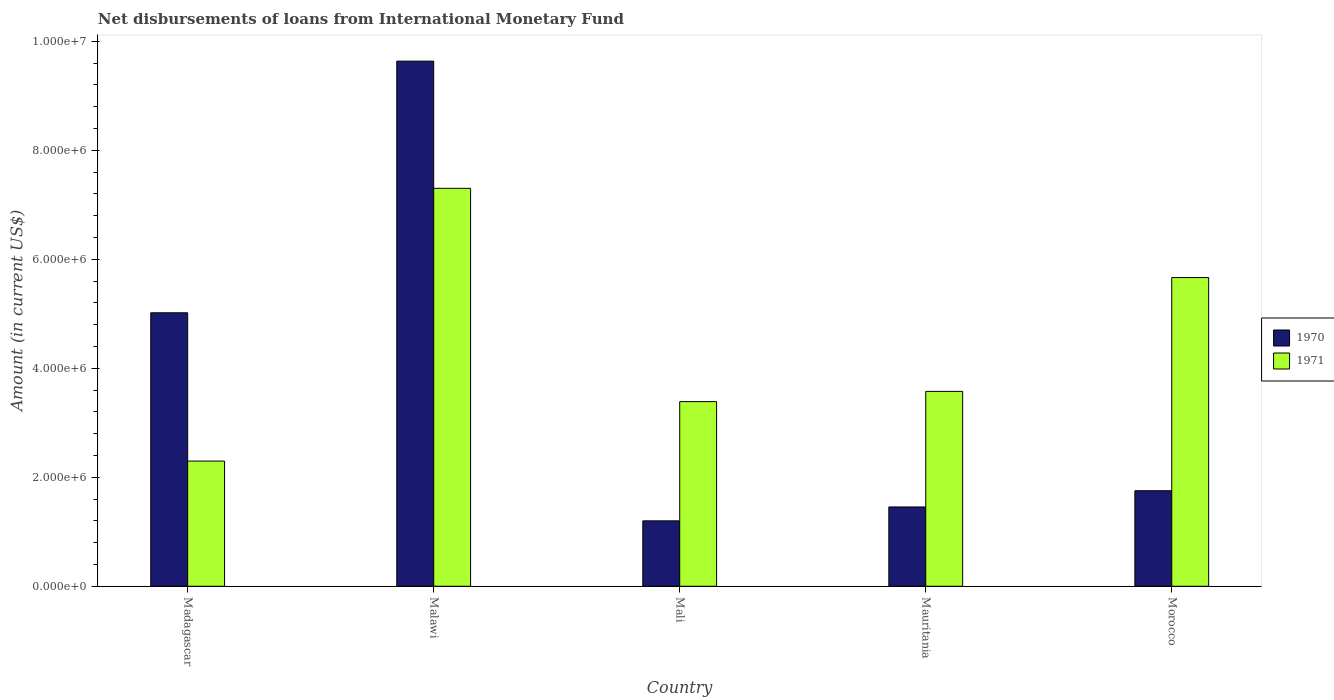How many different coloured bars are there?
Offer a very short reply. 2. How many groups of bars are there?
Make the answer very short. 5. Are the number of bars per tick equal to the number of legend labels?
Provide a short and direct response. Yes. Are the number of bars on each tick of the X-axis equal?
Make the answer very short. Yes. How many bars are there on the 5th tick from the right?
Give a very brief answer. 2. What is the label of the 3rd group of bars from the left?
Give a very brief answer. Mali. What is the amount of loans disbursed in 1971 in Mali?
Offer a terse response. 3.39e+06. Across all countries, what is the maximum amount of loans disbursed in 1970?
Your answer should be compact. 9.64e+06. Across all countries, what is the minimum amount of loans disbursed in 1971?
Provide a succinct answer. 2.30e+06. In which country was the amount of loans disbursed in 1970 maximum?
Give a very brief answer. Malawi. In which country was the amount of loans disbursed in 1970 minimum?
Ensure brevity in your answer.  Mali. What is the total amount of loans disbursed in 1971 in the graph?
Keep it short and to the point. 2.22e+07. What is the difference between the amount of loans disbursed in 1971 in Madagascar and that in Morocco?
Provide a short and direct response. -3.37e+06. What is the difference between the amount of loans disbursed in 1970 in Mauritania and the amount of loans disbursed in 1971 in Madagascar?
Make the answer very short. -8.42e+05. What is the average amount of loans disbursed in 1971 per country?
Ensure brevity in your answer.  4.45e+06. What is the difference between the amount of loans disbursed of/in 1970 and amount of loans disbursed of/in 1971 in Mauritania?
Keep it short and to the point. -2.12e+06. In how many countries, is the amount of loans disbursed in 1971 greater than 7600000 US$?
Offer a terse response. 0. What is the ratio of the amount of loans disbursed in 1970 in Mali to that in Mauritania?
Keep it short and to the point. 0.82. What is the difference between the highest and the second highest amount of loans disbursed in 1971?
Provide a short and direct response. 1.64e+06. What is the difference between the highest and the lowest amount of loans disbursed in 1971?
Provide a succinct answer. 5.00e+06. What does the 1st bar from the right in Malawi represents?
Offer a very short reply. 1971. How many bars are there?
Ensure brevity in your answer.  10. What is the difference between two consecutive major ticks on the Y-axis?
Offer a very short reply. 2.00e+06. Does the graph contain any zero values?
Ensure brevity in your answer.  No. Does the graph contain grids?
Offer a very short reply. No. Where does the legend appear in the graph?
Offer a terse response. Center right. How many legend labels are there?
Keep it short and to the point. 2. How are the legend labels stacked?
Your answer should be very brief. Vertical. What is the title of the graph?
Keep it short and to the point. Net disbursements of loans from International Monetary Fund. What is the Amount (in current US$) in 1970 in Madagascar?
Your response must be concise. 5.02e+06. What is the Amount (in current US$) of 1971 in Madagascar?
Offer a very short reply. 2.30e+06. What is the Amount (in current US$) of 1970 in Malawi?
Ensure brevity in your answer.  9.64e+06. What is the Amount (in current US$) of 1971 in Malawi?
Offer a terse response. 7.30e+06. What is the Amount (in current US$) of 1970 in Mali?
Your answer should be very brief. 1.20e+06. What is the Amount (in current US$) of 1971 in Mali?
Your response must be concise. 3.39e+06. What is the Amount (in current US$) in 1970 in Mauritania?
Your answer should be compact. 1.46e+06. What is the Amount (in current US$) of 1971 in Mauritania?
Your answer should be compact. 3.58e+06. What is the Amount (in current US$) in 1970 in Morocco?
Make the answer very short. 1.75e+06. What is the Amount (in current US$) of 1971 in Morocco?
Offer a very short reply. 5.66e+06. Across all countries, what is the maximum Amount (in current US$) in 1970?
Provide a succinct answer. 9.64e+06. Across all countries, what is the maximum Amount (in current US$) in 1971?
Your answer should be compact. 7.30e+06. Across all countries, what is the minimum Amount (in current US$) in 1970?
Give a very brief answer. 1.20e+06. Across all countries, what is the minimum Amount (in current US$) of 1971?
Your response must be concise. 2.30e+06. What is the total Amount (in current US$) in 1970 in the graph?
Provide a succinct answer. 1.91e+07. What is the total Amount (in current US$) of 1971 in the graph?
Make the answer very short. 2.22e+07. What is the difference between the Amount (in current US$) of 1970 in Madagascar and that in Malawi?
Give a very brief answer. -4.62e+06. What is the difference between the Amount (in current US$) in 1971 in Madagascar and that in Malawi?
Your answer should be very brief. -5.00e+06. What is the difference between the Amount (in current US$) of 1970 in Madagascar and that in Mali?
Make the answer very short. 3.82e+06. What is the difference between the Amount (in current US$) in 1971 in Madagascar and that in Mali?
Provide a short and direct response. -1.09e+06. What is the difference between the Amount (in current US$) in 1970 in Madagascar and that in Mauritania?
Your answer should be very brief. 3.56e+06. What is the difference between the Amount (in current US$) in 1971 in Madagascar and that in Mauritania?
Your answer should be very brief. -1.28e+06. What is the difference between the Amount (in current US$) in 1970 in Madagascar and that in Morocco?
Make the answer very short. 3.26e+06. What is the difference between the Amount (in current US$) of 1971 in Madagascar and that in Morocco?
Your answer should be very brief. -3.37e+06. What is the difference between the Amount (in current US$) of 1970 in Malawi and that in Mali?
Offer a terse response. 8.44e+06. What is the difference between the Amount (in current US$) in 1971 in Malawi and that in Mali?
Keep it short and to the point. 3.91e+06. What is the difference between the Amount (in current US$) in 1970 in Malawi and that in Mauritania?
Offer a terse response. 8.18e+06. What is the difference between the Amount (in current US$) in 1971 in Malawi and that in Mauritania?
Provide a short and direct response. 3.73e+06. What is the difference between the Amount (in current US$) in 1970 in Malawi and that in Morocco?
Ensure brevity in your answer.  7.88e+06. What is the difference between the Amount (in current US$) in 1971 in Malawi and that in Morocco?
Make the answer very short. 1.64e+06. What is the difference between the Amount (in current US$) of 1970 in Mali and that in Mauritania?
Offer a terse response. -2.55e+05. What is the difference between the Amount (in current US$) in 1971 in Mali and that in Mauritania?
Your answer should be compact. -1.88e+05. What is the difference between the Amount (in current US$) in 1970 in Mali and that in Morocco?
Offer a very short reply. -5.53e+05. What is the difference between the Amount (in current US$) in 1971 in Mali and that in Morocco?
Give a very brief answer. -2.28e+06. What is the difference between the Amount (in current US$) of 1970 in Mauritania and that in Morocco?
Your answer should be very brief. -2.98e+05. What is the difference between the Amount (in current US$) in 1971 in Mauritania and that in Morocco?
Your response must be concise. -2.09e+06. What is the difference between the Amount (in current US$) in 1970 in Madagascar and the Amount (in current US$) in 1971 in Malawi?
Your answer should be very brief. -2.28e+06. What is the difference between the Amount (in current US$) of 1970 in Madagascar and the Amount (in current US$) of 1971 in Mali?
Give a very brief answer. 1.63e+06. What is the difference between the Amount (in current US$) of 1970 in Madagascar and the Amount (in current US$) of 1971 in Mauritania?
Offer a very short reply. 1.44e+06. What is the difference between the Amount (in current US$) of 1970 in Madagascar and the Amount (in current US$) of 1971 in Morocco?
Provide a succinct answer. -6.47e+05. What is the difference between the Amount (in current US$) of 1970 in Malawi and the Amount (in current US$) of 1971 in Mali?
Provide a succinct answer. 6.25e+06. What is the difference between the Amount (in current US$) in 1970 in Malawi and the Amount (in current US$) in 1971 in Mauritania?
Your response must be concise. 6.06e+06. What is the difference between the Amount (in current US$) in 1970 in Malawi and the Amount (in current US$) in 1971 in Morocco?
Give a very brief answer. 3.97e+06. What is the difference between the Amount (in current US$) of 1970 in Mali and the Amount (in current US$) of 1971 in Mauritania?
Provide a short and direct response. -2.38e+06. What is the difference between the Amount (in current US$) in 1970 in Mali and the Amount (in current US$) in 1971 in Morocco?
Give a very brief answer. -4.46e+06. What is the difference between the Amount (in current US$) in 1970 in Mauritania and the Amount (in current US$) in 1971 in Morocco?
Your response must be concise. -4.21e+06. What is the average Amount (in current US$) of 1970 per country?
Offer a very short reply. 3.81e+06. What is the average Amount (in current US$) of 1971 per country?
Keep it short and to the point. 4.45e+06. What is the difference between the Amount (in current US$) in 1970 and Amount (in current US$) in 1971 in Madagascar?
Your answer should be compact. 2.72e+06. What is the difference between the Amount (in current US$) in 1970 and Amount (in current US$) in 1971 in Malawi?
Offer a very short reply. 2.33e+06. What is the difference between the Amount (in current US$) of 1970 and Amount (in current US$) of 1971 in Mali?
Provide a short and direct response. -2.19e+06. What is the difference between the Amount (in current US$) in 1970 and Amount (in current US$) in 1971 in Mauritania?
Your response must be concise. -2.12e+06. What is the difference between the Amount (in current US$) of 1970 and Amount (in current US$) of 1971 in Morocco?
Your response must be concise. -3.91e+06. What is the ratio of the Amount (in current US$) of 1970 in Madagascar to that in Malawi?
Keep it short and to the point. 0.52. What is the ratio of the Amount (in current US$) in 1971 in Madagascar to that in Malawi?
Your answer should be compact. 0.31. What is the ratio of the Amount (in current US$) of 1970 in Madagascar to that in Mali?
Offer a terse response. 4.18. What is the ratio of the Amount (in current US$) of 1971 in Madagascar to that in Mali?
Make the answer very short. 0.68. What is the ratio of the Amount (in current US$) in 1970 in Madagascar to that in Mauritania?
Your answer should be compact. 3.45. What is the ratio of the Amount (in current US$) in 1971 in Madagascar to that in Mauritania?
Offer a terse response. 0.64. What is the ratio of the Amount (in current US$) in 1970 in Madagascar to that in Morocco?
Your response must be concise. 2.86. What is the ratio of the Amount (in current US$) in 1971 in Madagascar to that in Morocco?
Provide a short and direct response. 0.41. What is the ratio of the Amount (in current US$) of 1970 in Malawi to that in Mali?
Offer a very short reply. 8.03. What is the ratio of the Amount (in current US$) of 1971 in Malawi to that in Mali?
Provide a succinct answer. 2.16. What is the ratio of the Amount (in current US$) of 1970 in Malawi to that in Mauritania?
Offer a terse response. 6.62. What is the ratio of the Amount (in current US$) in 1971 in Malawi to that in Mauritania?
Your answer should be compact. 2.04. What is the ratio of the Amount (in current US$) in 1970 in Malawi to that in Morocco?
Your response must be concise. 5.5. What is the ratio of the Amount (in current US$) in 1971 in Malawi to that in Morocco?
Provide a succinct answer. 1.29. What is the ratio of the Amount (in current US$) of 1970 in Mali to that in Mauritania?
Provide a succinct answer. 0.82. What is the ratio of the Amount (in current US$) of 1971 in Mali to that in Mauritania?
Provide a succinct answer. 0.95. What is the ratio of the Amount (in current US$) in 1970 in Mali to that in Morocco?
Provide a succinct answer. 0.68. What is the ratio of the Amount (in current US$) in 1971 in Mali to that in Morocco?
Your answer should be compact. 0.6. What is the ratio of the Amount (in current US$) of 1970 in Mauritania to that in Morocco?
Offer a very short reply. 0.83. What is the ratio of the Amount (in current US$) in 1971 in Mauritania to that in Morocco?
Provide a succinct answer. 0.63. What is the difference between the highest and the second highest Amount (in current US$) of 1970?
Your answer should be compact. 4.62e+06. What is the difference between the highest and the second highest Amount (in current US$) of 1971?
Offer a very short reply. 1.64e+06. What is the difference between the highest and the lowest Amount (in current US$) of 1970?
Offer a very short reply. 8.44e+06. What is the difference between the highest and the lowest Amount (in current US$) in 1971?
Offer a very short reply. 5.00e+06. 